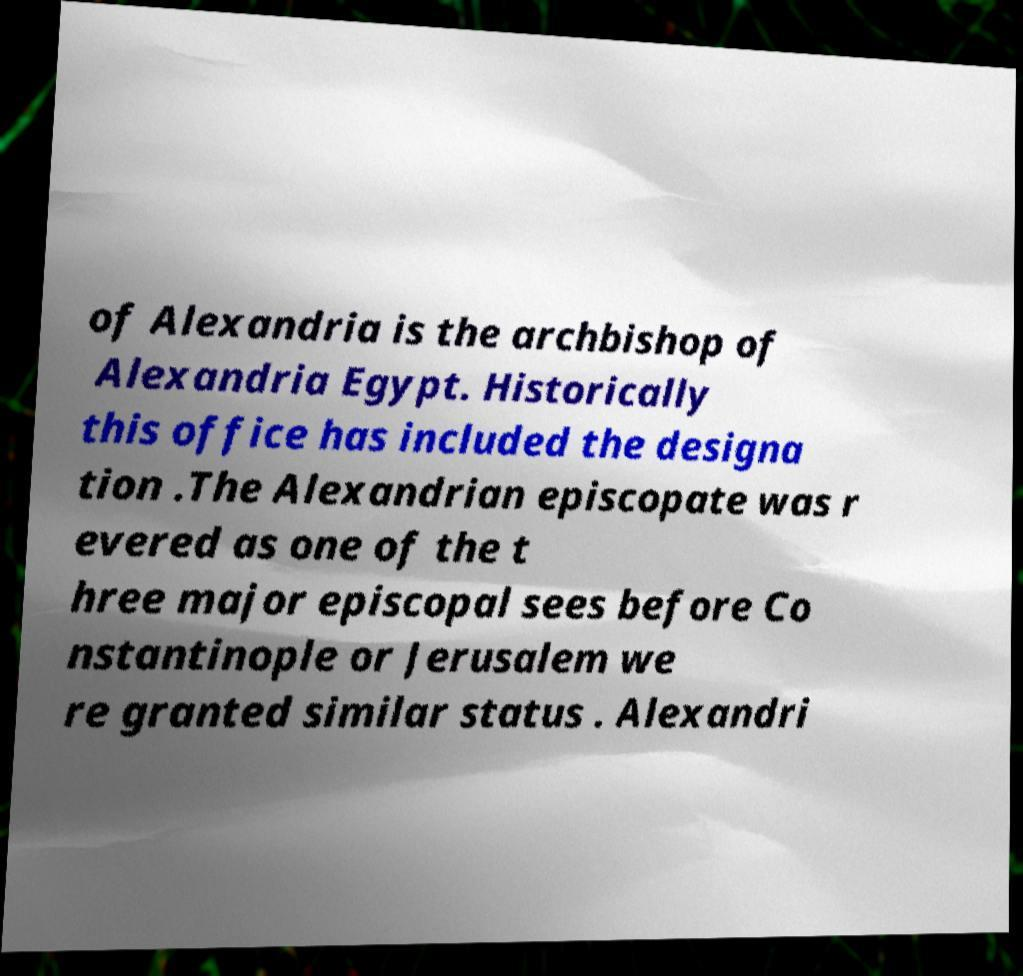Please read and relay the text visible in this image. What does it say? of Alexandria is the archbishop of Alexandria Egypt. Historically this office has included the designa tion .The Alexandrian episcopate was r evered as one of the t hree major episcopal sees before Co nstantinople or Jerusalem we re granted similar status . Alexandri 